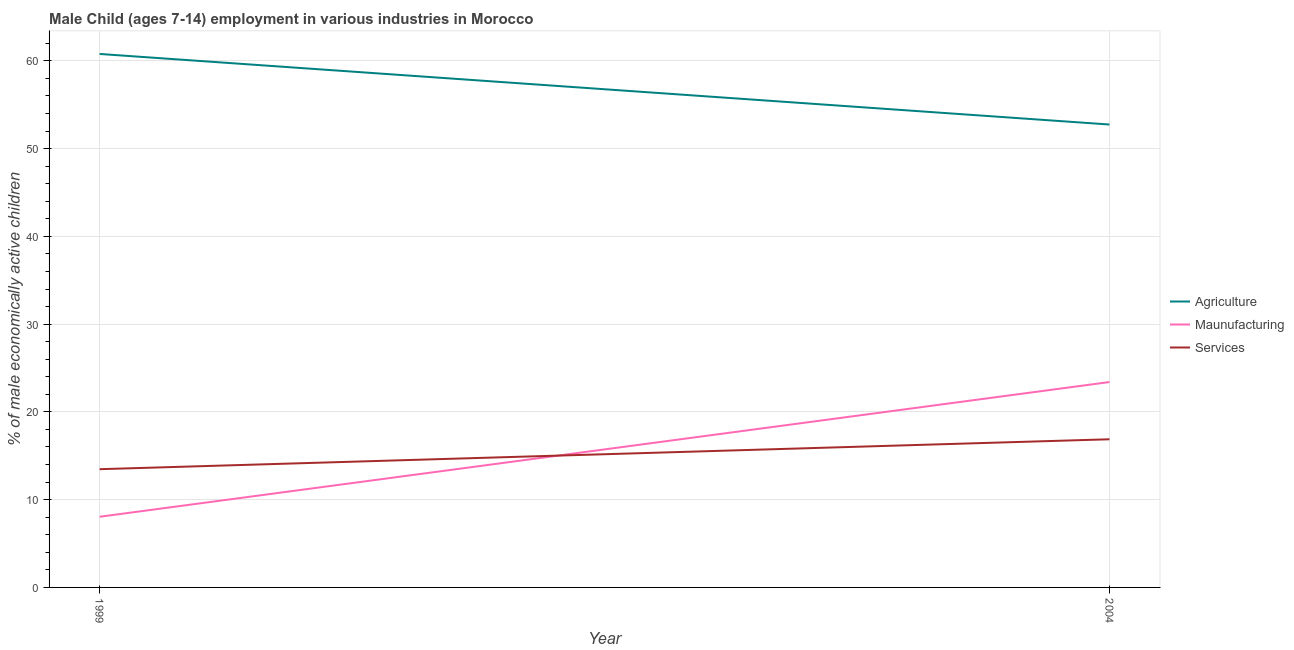What is the percentage of economically active children in agriculture in 2004?
Keep it short and to the point. 52.74. Across all years, what is the maximum percentage of economically active children in agriculture?
Your response must be concise. 60.78. Across all years, what is the minimum percentage of economically active children in agriculture?
Offer a terse response. 52.74. In which year was the percentage of economically active children in services maximum?
Make the answer very short. 2004. What is the total percentage of economically active children in agriculture in the graph?
Keep it short and to the point. 113.52. What is the difference between the percentage of economically active children in manufacturing in 1999 and that in 2004?
Provide a succinct answer. -15.35. What is the difference between the percentage of economically active children in agriculture in 1999 and the percentage of economically active children in manufacturing in 2004?
Your answer should be very brief. 37.38. What is the average percentage of economically active children in agriculture per year?
Your answer should be very brief. 56.76. In the year 1999, what is the difference between the percentage of economically active children in agriculture and percentage of economically active children in manufacturing?
Ensure brevity in your answer.  52.73. What is the ratio of the percentage of economically active children in agriculture in 1999 to that in 2004?
Ensure brevity in your answer.  1.15. Is the percentage of economically active children in agriculture in 1999 less than that in 2004?
Your answer should be very brief. No. Does the graph contain grids?
Keep it short and to the point. Yes. Where does the legend appear in the graph?
Provide a succinct answer. Center right. How are the legend labels stacked?
Your response must be concise. Vertical. What is the title of the graph?
Offer a terse response. Male Child (ages 7-14) employment in various industries in Morocco. What is the label or title of the Y-axis?
Your answer should be very brief. % of male economically active children. What is the % of male economically active children in Agriculture in 1999?
Your answer should be compact. 60.78. What is the % of male economically active children in Maunufacturing in 1999?
Provide a short and direct response. 8.05. What is the % of male economically active children of Services in 1999?
Offer a terse response. 13.47. What is the % of male economically active children in Agriculture in 2004?
Make the answer very short. 52.74. What is the % of male economically active children of Maunufacturing in 2004?
Provide a succinct answer. 23.4. What is the % of male economically active children in Services in 2004?
Provide a succinct answer. 16.88. Across all years, what is the maximum % of male economically active children of Agriculture?
Keep it short and to the point. 60.78. Across all years, what is the maximum % of male economically active children of Maunufacturing?
Give a very brief answer. 23.4. Across all years, what is the maximum % of male economically active children of Services?
Offer a terse response. 16.88. Across all years, what is the minimum % of male economically active children of Agriculture?
Provide a succinct answer. 52.74. Across all years, what is the minimum % of male economically active children of Maunufacturing?
Offer a terse response. 8.05. Across all years, what is the minimum % of male economically active children in Services?
Your answer should be very brief. 13.47. What is the total % of male economically active children in Agriculture in the graph?
Offer a terse response. 113.52. What is the total % of male economically active children of Maunufacturing in the graph?
Offer a terse response. 31.45. What is the total % of male economically active children of Services in the graph?
Your answer should be compact. 30.35. What is the difference between the % of male economically active children of Agriculture in 1999 and that in 2004?
Give a very brief answer. 8.04. What is the difference between the % of male economically active children of Maunufacturing in 1999 and that in 2004?
Keep it short and to the point. -15.35. What is the difference between the % of male economically active children in Services in 1999 and that in 2004?
Keep it short and to the point. -3.41. What is the difference between the % of male economically active children of Agriculture in 1999 and the % of male economically active children of Maunufacturing in 2004?
Keep it short and to the point. 37.38. What is the difference between the % of male economically active children in Agriculture in 1999 and the % of male economically active children in Services in 2004?
Keep it short and to the point. 43.9. What is the difference between the % of male economically active children of Maunufacturing in 1999 and the % of male economically active children of Services in 2004?
Provide a succinct answer. -8.83. What is the average % of male economically active children of Agriculture per year?
Your answer should be very brief. 56.76. What is the average % of male economically active children in Maunufacturing per year?
Offer a terse response. 15.72. What is the average % of male economically active children in Services per year?
Keep it short and to the point. 15.18. In the year 1999, what is the difference between the % of male economically active children of Agriculture and % of male economically active children of Maunufacturing?
Offer a very short reply. 52.73. In the year 1999, what is the difference between the % of male economically active children of Agriculture and % of male economically active children of Services?
Your answer should be very brief. 47.31. In the year 1999, what is the difference between the % of male economically active children of Maunufacturing and % of male economically active children of Services?
Keep it short and to the point. -5.42. In the year 2004, what is the difference between the % of male economically active children in Agriculture and % of male economically active children in Maunufacturing?
Make the answer very short. 29.34. In the year 2004, what is the difference between the % of male economically active children in Agriculture and % of male economically active children in Services?
Ensure brevity in your answer.  35.86. In the year 2004, what is the difference between the % of male economically active children in Maunufacturing and % of male economically active children in Services?
Your answer should be compact. 6.52. What is the ratio of the % of male economically active children in Agriculture in 1999 to that in 2004?
Ensure brevity in your answer.  1.15. What is the ratio of the % of male economically active children of Maunufacturing in 1999 to that in 2004?
Provide a short and direct response. 0.34. What is the ratio of the % of male economically active children of Services in 1999 to that in 2004?
Offer a very short reply. 0.8. What is the difference between the highest and the second highest % of male economically active children in Agriculture?
Your answer should be very brief. 8.04. What is the difference between the highest and the second highest % of male economically active children in Maunufacturing?
Offer a terse response. 15.35. What is the difference between the highest and the second highest % of male economically active children of Services?
Make the answer very short. 3.41. What is the difference between the highest and the lowest % of male economically active children of Agriculture?
Offer a terse response. 8.04. What is the difference between the highest and the lowest % of male economically active children of Maunufacturing?
Your response must be concise. 15.35. What is the difference between the highest and the lowest % of male economically active children in Services?
Offer a terse response. 3.41. 